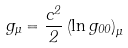<formula> <loc_0><loc_0><loc_500><loc_500>g _ { \mu } = \frac { c ^ { 2 } } 2 \left ( \ln g _ { 0 0 } \right ) _ { \mu }</formula> 